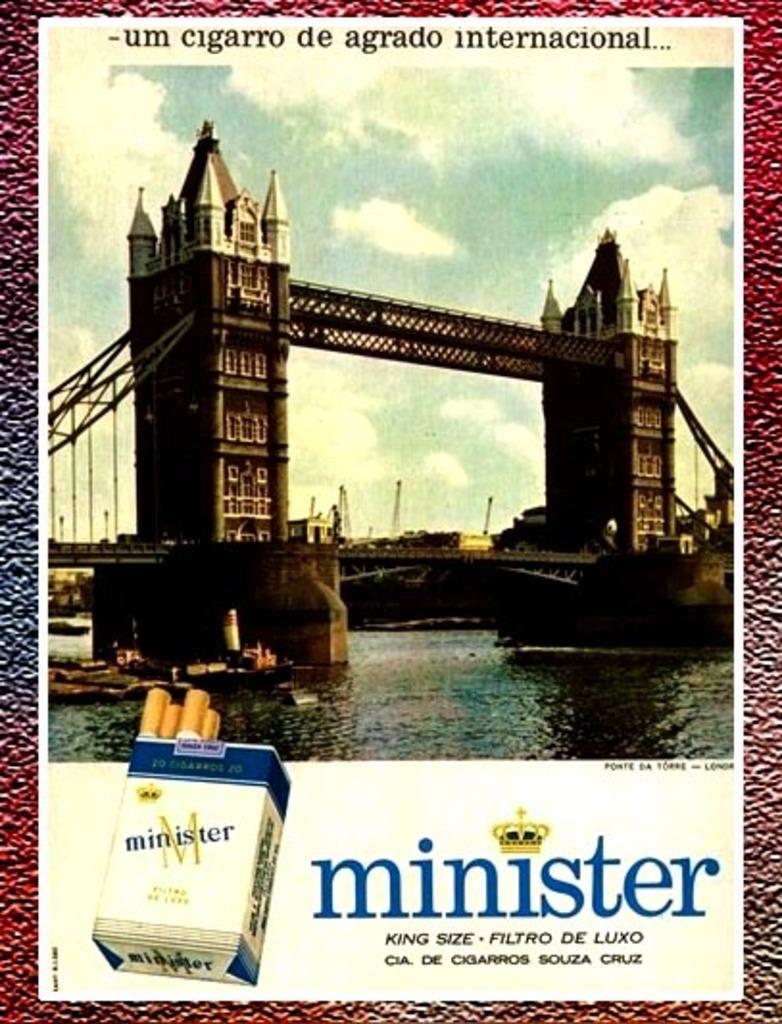<image>
Share a concise interpretation of the image provided. Poster showing a bridge and minister cigarettes on the bottom. 